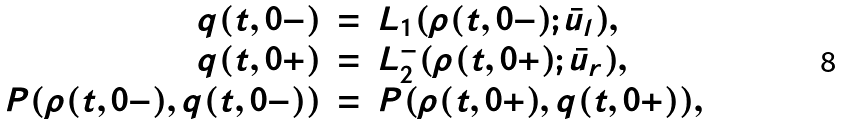Convert formula to latex. <formula><loc_0><loc_0><loc_500><loc_500>\begin{array} { r c l } q ( t , 0 - ) & = & L _ { 1 } ( \rho ( t , 0 - ) ; \bar { u } _ { l } ) , \\ q ( t , 0 + ) & = & L _ { 2 } ^ { - } ( \rho ( t , 0 + ) ; \bar { u } _ { r } ) , \\ P ( \rho ( t , 0 - ) , q ( t , 0 - ) ) & = & P ( \rho ( t , 0 + ) , q ( t , 0 + ) ) , \end{array}</formula> 